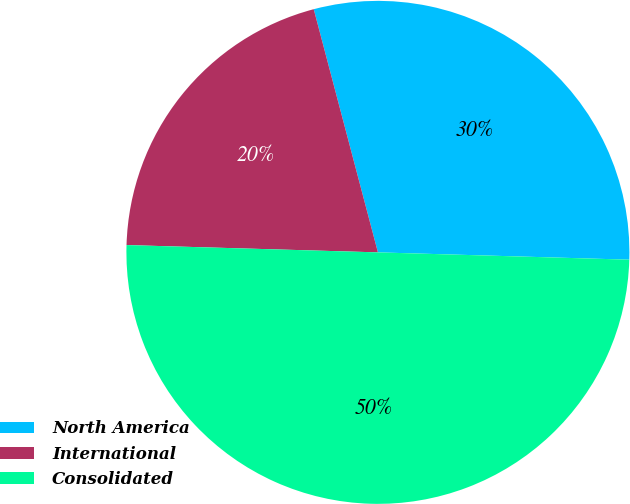<chart> <loc_0><loc_0><loc_500><loc_500><pie_chart><fcel>North America<fcel>International<fcel>Consolidated<nl><fcel>29.57%<fcel>20.43%<fcel>50.0%<nl></chart> 